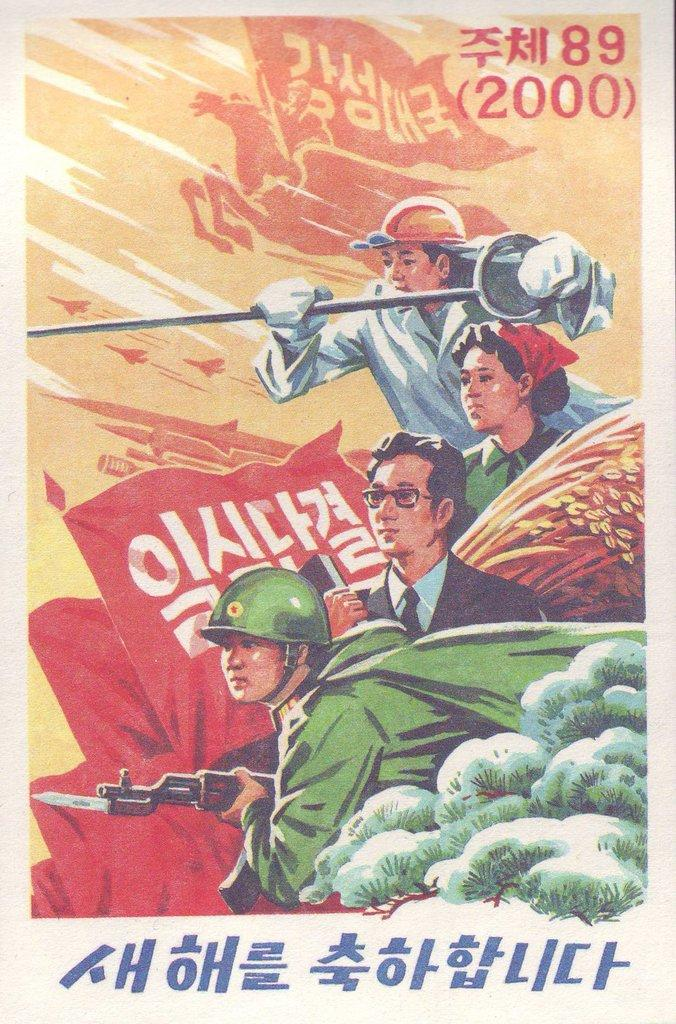<image>
Write a terse but informative summary of the picture. A poster with foreign characters on it that also has the numbers 89 and 2000 in the top right corner. 